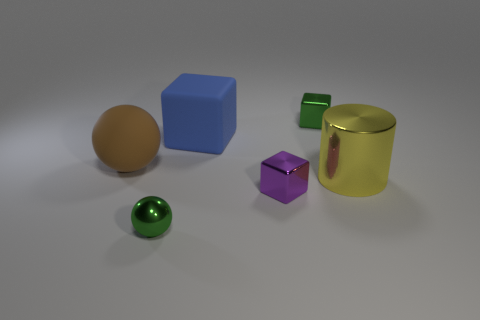Add 3 blue metallic cylinders. How many objects exist? 9 Subtract all balls. How many objects are left? 4 Subtract all purple metallic cylinders. Subtract all purple shiny blocks. How many objects are left? 5 Add 5 tiny cubes. How many tiny cubes are left? 7 Add 4 large blue objects. How many large blue objects exist? 5 Subtract 0 yellow cubes. How many objects are left? 6 